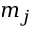<formula> <loc_0><loc_0><loc_500><loc_500>m _ { j }</formula> 